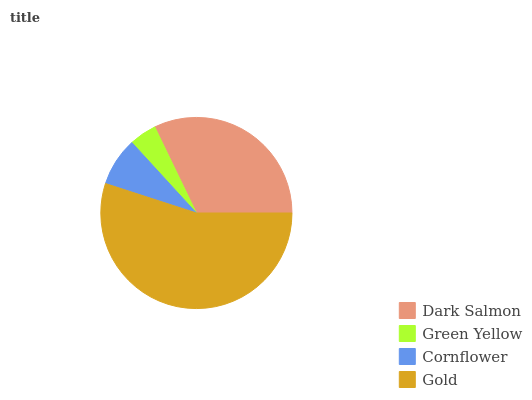Is Green Yellow the minimum?
Answer yes or no. Yes. Is Gold the maximum?
Answer yes or no. Yes. Is Cornflower the minimum?
Answer yes or no. No. Is Cornflower the maximum?
Answer yes or no. No. Is Cornflower greater than Green Yellow?
Answer yes or no. Yes. Is Green Yellow less than Cornflower?
Answer yes or no. Yes. Is Green Yellow greater than Cornflower?
Answer yes or no. No. Is Cornflower less than Green Yellow?
Answer yes or no. No. Is Dark Salmon the high median?
Answer yes or no. Yes. Is Cornflower the low median?
Answer yes or no. Yes. Is Green Yellow the high median?
Answer yes or no. No. Is Dark Salmon the low median?
Answer yes or no. No. 